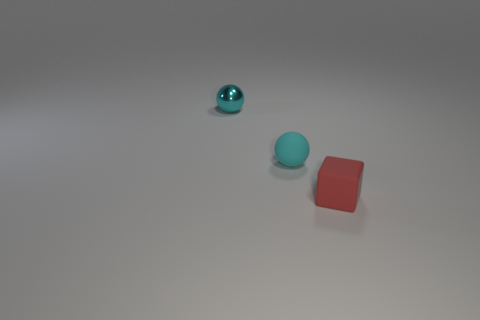There is another sphere that is the same color as the rubber ball; what is it made of?
Provide a succinct answer. Metal. How many other objects are the same material as the cube?
Provide a short and direct response. 1. Is the shape of the tiny cyan matte thing the same as the tiny rubber object that is to the right of the small cyan rubber sphere?
Make the answer very short. No. The small thing that is made of the same material as the tiny cube is what shape?
Offer a terse response. Sphere. Is the number of red objects to the left of the tiny cyan metal thing greater than the number of small rubber cubes left of the small cyan matte thing?
Your response must be concise. No. What number of things are tiny metal things or big gray rubber cylinders?
Ensure brevity in your answer.  1. How many other objects are there of the same color as the small matte cube?
Your answer should be compact. 0. There is a red matte thing that is the same size as the shiny object; what shape is it?
Give a very brief answer. Cube. There is a rubber object on the left side of the red matte cube; what is its color?
Offer a terse response. Cyan. What number of objects are small cyan balls that are in front of the cyan metal object or tiny cyan balls to the right of the small shiny sphere?
Make the answer very short. 1. 